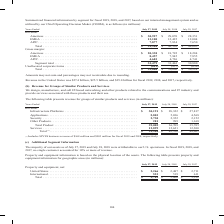From Cisco Systems's financial document, Which years does the table provide information for the company's property and equipment based on the physical location of the assets? The document contains multiple relevant values: 2019, 2018, 2017. From the document: "Years Ended July 27, 2019 July 28, 2018 July 29, 2017 Revenue: Americas . $ 30,927 $ 29,070 $ 28,351 EMEA . 13,100 12,425 12,004 APJC. . 7,877 7,834 7..." Also, What was the net property and equipment from United States in 2019? According to the financial document, 2,266 (in millions). The relevant text states: "17 Property and equipment, net: United States . $ 2,266 $ 2,487 $ 2,711 International. . 523 519 611 Total . $ 2,789 $ 3,006 $ 3,322..." Also, What was the net property and equipment from International regions in 2018? According to the financial document, 519 (in millions). The relevant text states: "es . $ 2,266 $ 2,487 $ 2,711 International. . 523 519 611 Total . $ 2,789 $ 3,006 $ 3,322..." Also, can you calculate: What was the change in net property and equipment from United States between 2017 and 2018? Based on the calculation: 2,487-2,711, the result is -224 (in millions). This is based on the information: "rty and equipment, net: United States . $ 2,266 $ 2,487 $ 2,711 International. . 523 519 611 Total . $ 2,789 $ 3,006 $ 3,322 equipment, net: United States . $ 2,266 $ 2,487 $ 2,711 International. . 52..." The key data points involved are: 2,487, 2,711. Also, can you calculate: What was the change in net property and equipment from International regions between 2017 and 2018? Based on the calculation: 519-611, the result is -92 (in millions). This is based on the information: "$ 2,266 $ 2,487 $ 2,711 International. . 523 519 611 Total . $ 2,789 $ 3,006 $ 3,322 es . $ 2,266 $ 2,487 $ 2,711 International. . 523 519 611 Total . $ 2,789 $ 3,006 $ 3,322..." The key data points involved are: 519, 611. Also, can you calculate: What was the percentage change in the total net property and equipment between 2018 and 2019? To answer this question, I need to perform calculations using the financial data. The calculation is: (2,789-3,006)/3,006, which equals -7.22 (percentage). This is based on the information: "11 International. . 523 519 611 Total . $ 2,789 $ 3,006 $ 3,322 87 $ 2,711 International. . 523 519 611 Total . $ 2,789 $ 3,006 $ 3,322..." The key data points involved are: 2,789, 3,006. 